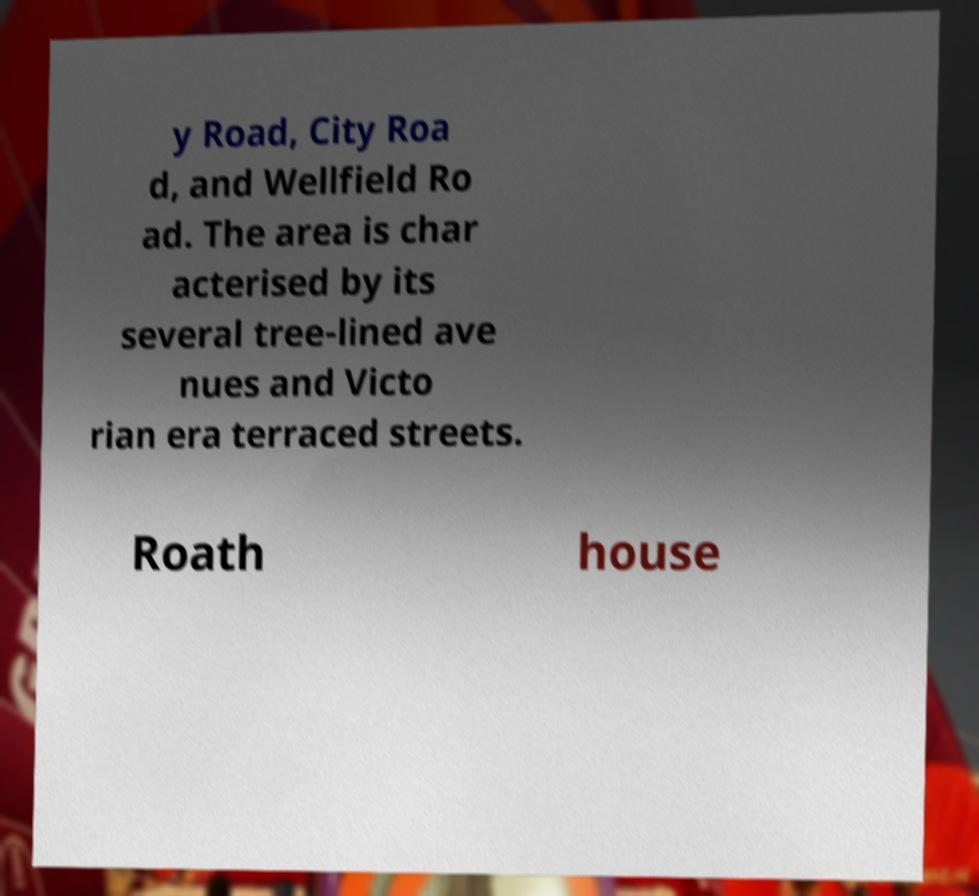I need the written content from this picture converted into text. Can you do that? y Road, City Roa d, and Wellfield Ro ad. The area is char acterised by its several tree-lined ave nues and Victo rian era terraced streets. Roath house 